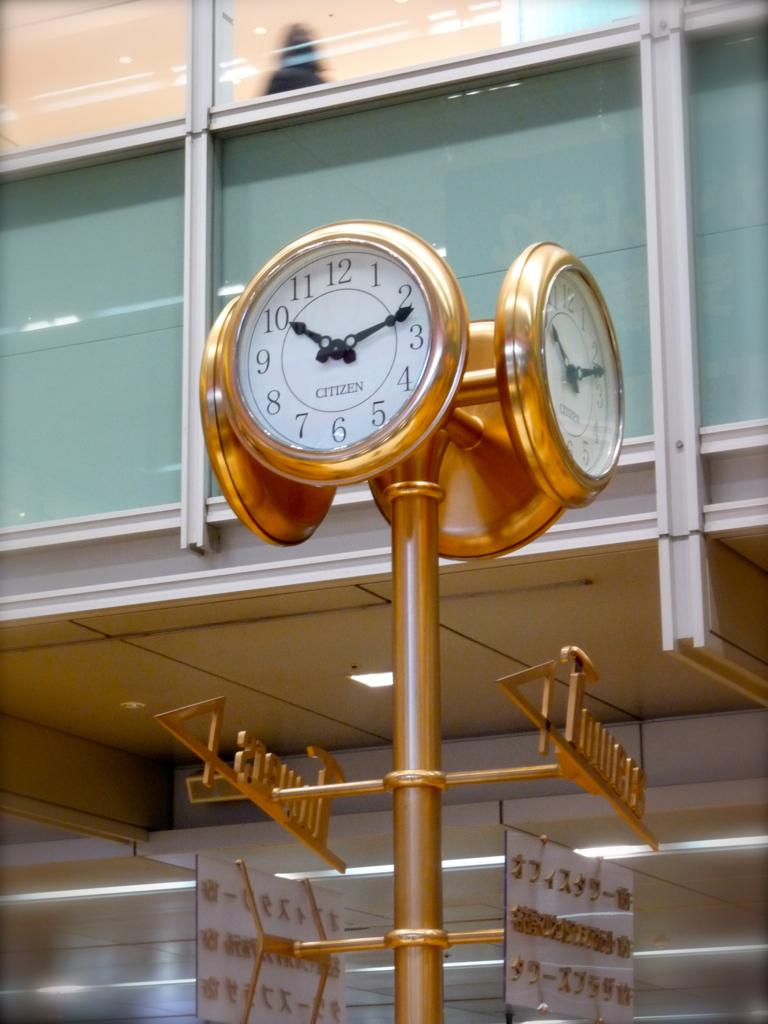<image>
Create a compact narrative representing the image presented. A clock is adorned with the brand-name Citizen. 